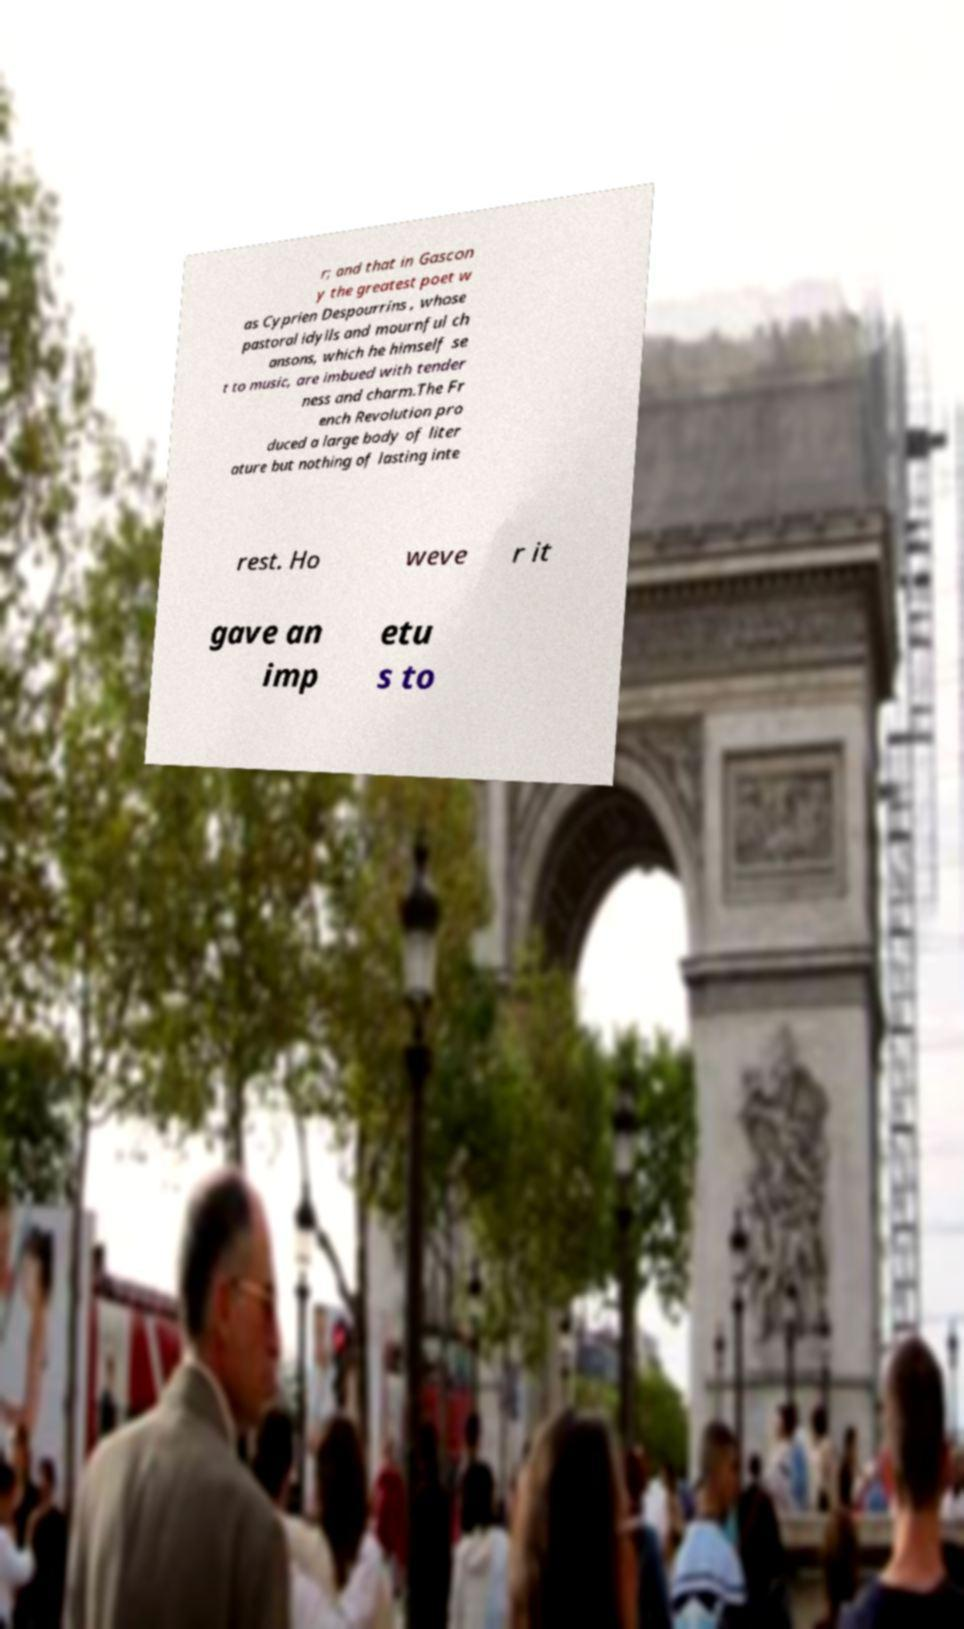I need the written content from this picture converted into text. Can you do that? r; and that in Gascon y the greatest poet w as Cyprien Despourrins , whose pastoral idylls and mournful ch ansons, which he himself se t to music, are imbued with tender ness and charm.The Fr ench Revolution pro duced a large body of liter ature but nothing of lasting inte rest. Ho weve r it gave an imp etu s to 